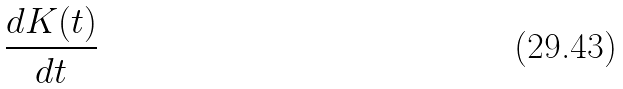Convert formula to latex. <formula><loc_0><loc_0><loc_500><loc_500>\frac { d K ( t ) } { d t }</formula> 